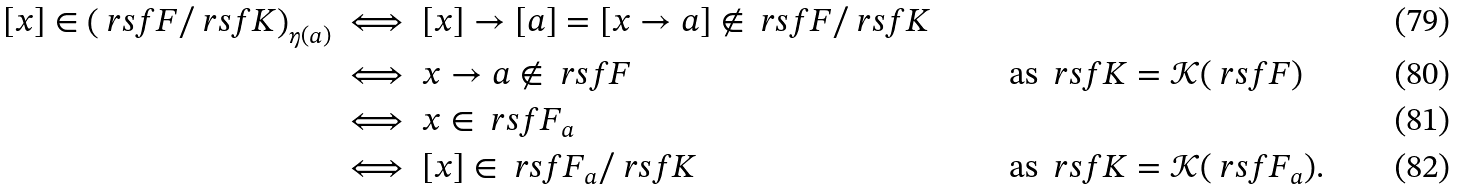<formula> <loc_0><loc_0><loc_500><loc_500>[ x ] \in \left ( \ r s f F / \ r s f K \right ) _ { \eta ( a ) } & \iff [ x ] \to [ a ] = [ x \to a ] \notin \ r s f F / \ r s f K \\ & \iff x \to a \notin \ r s f F & & \text { as } \ r s f K = \mathcal { K } ( \ r s f F ) \\ & \iff x \in \ r s f F _ { a } \\ & \iff [ x ] \in \ r s f F _ { a } / \ r s f K & & \text { as } \ r s f K = \mathcal { K } ( \ r s f F _ { a } ) .</formula> 